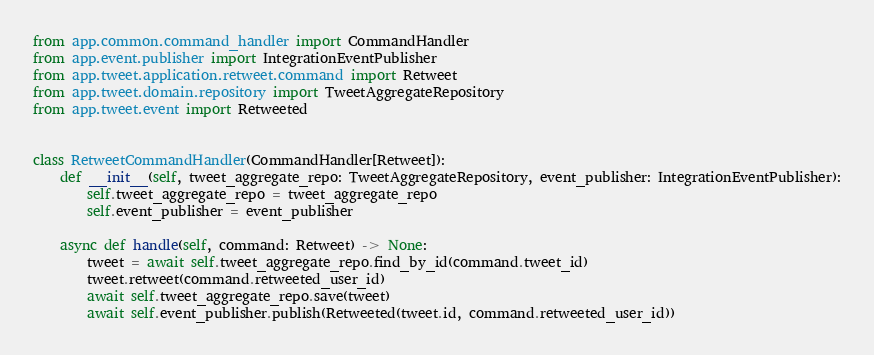<code> <loc_0><loc_0><loc_500><loc_500><_Python_>from app.common.command_handler import CommandHandler
from app.event.publisher import IntegrationEventPublisher
from app.tweet.application.retweet.command import Retweet
from app.tweet.domain.repository import TweetAggregateRepository
from app.tweet.event import Retweeted


class RetweetCommandHandler(CommandHandler[Retweet]):
    def __init__(self, tweet_aggregate_repo: TweetAggregateRepository, event_publisher: IntegrationEventPublisher):
        self.tweet_aggregate_repo = tweet_aggregate_repo
        self.event_publisher = event_publisher

    async def handle(self, command: Retweet) -> None:
        tweet = await self.tweet_aggregate_repo.find_by_id(command.tweet_id)
        tweet.retweet(command.retweeted_user_id)
        await self.tweet_aggregate_repo.save(tweet)
        await self.event_publisher.publish(Retweeted(tweet.id, command.retweeted_user_id))
</code> 